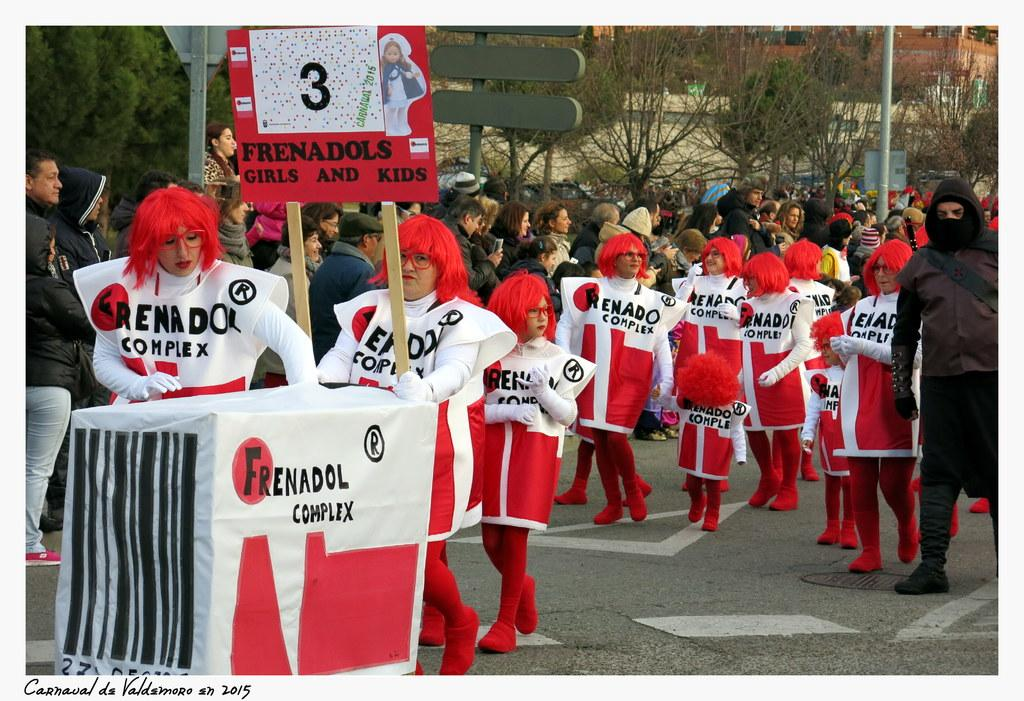<image>
Describe the image concisely. People dresed in red and white, one of whom is carrying a placard with the number 3 